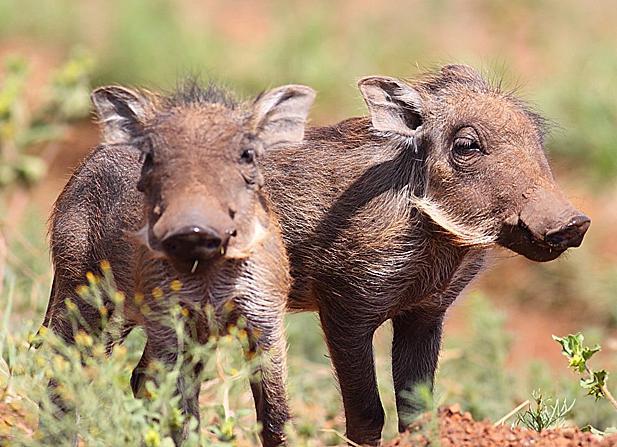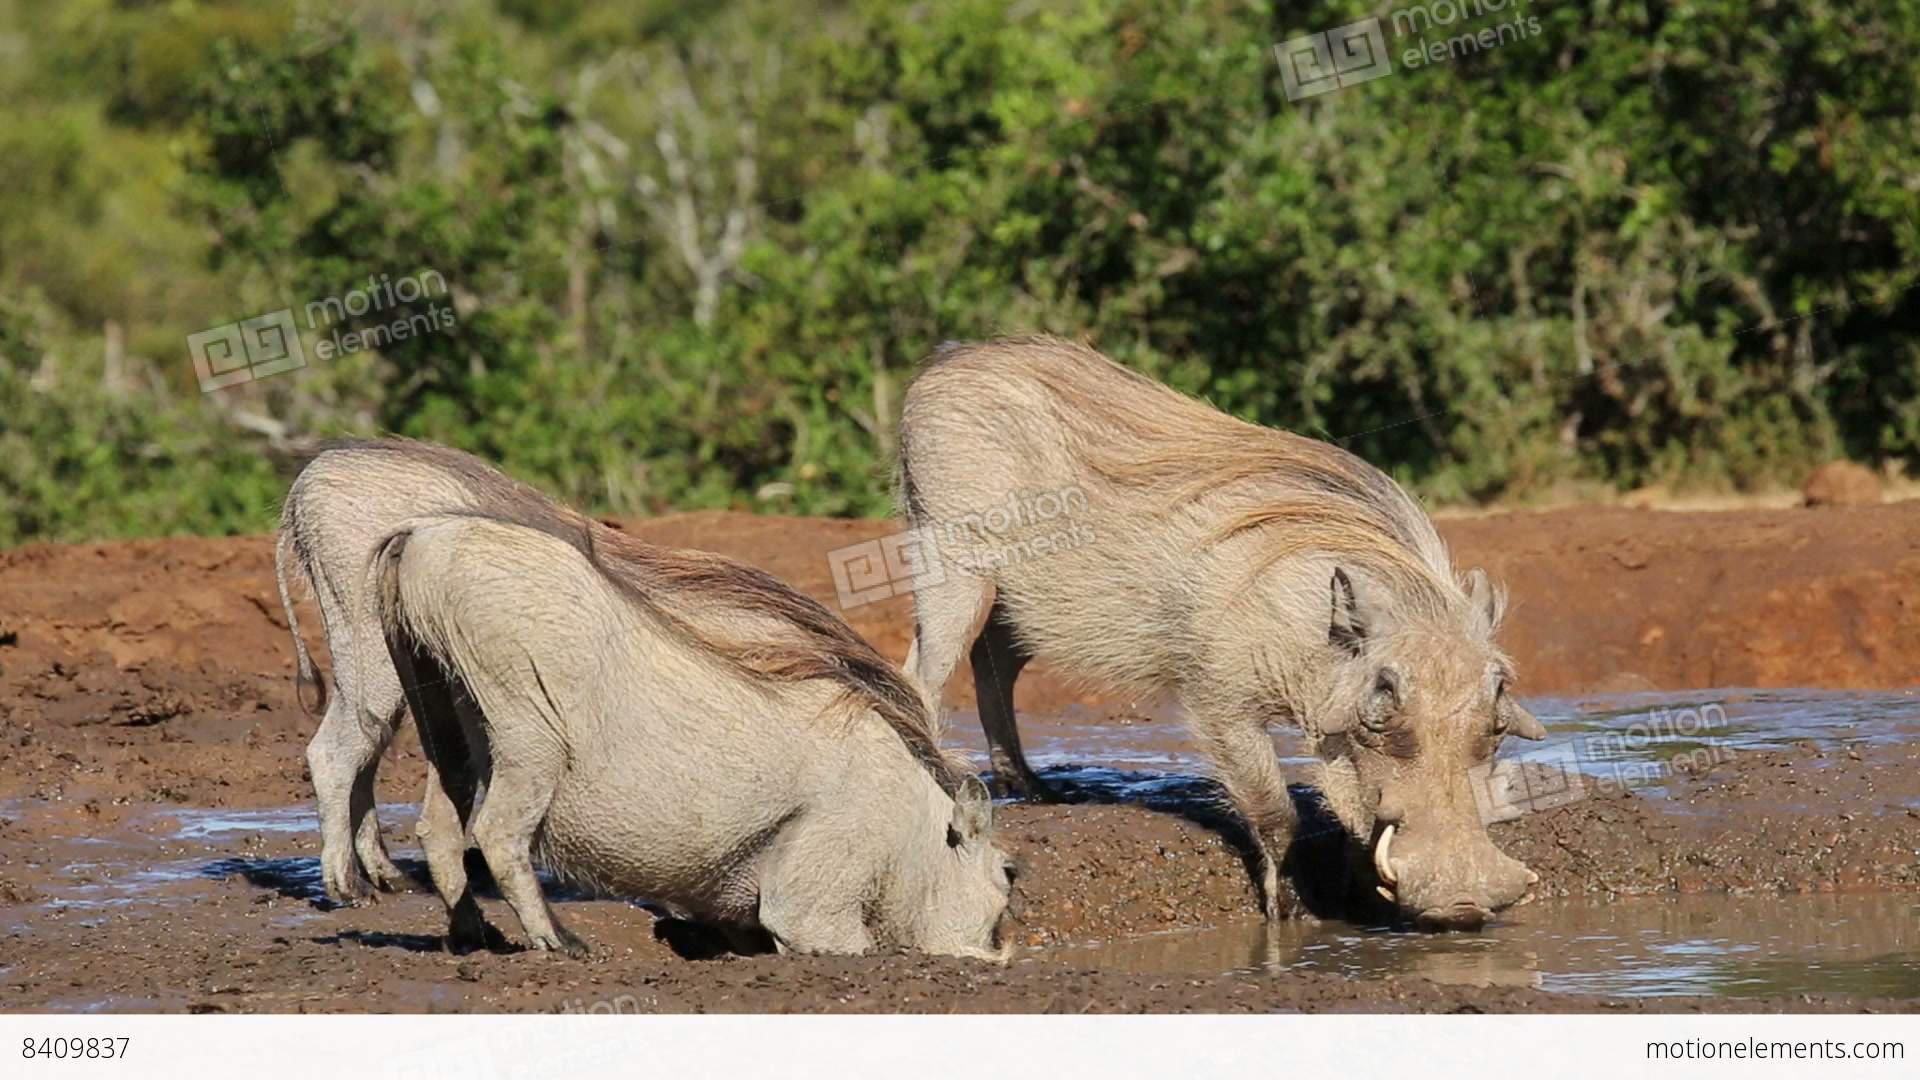The first image is the image on the left, the second image is the image on the right. Given the left and right images, does the statement "In one image two warthog is drinking out of a lake." hold true? Answer yes or no. Yes. The first image is the image on the left, the second image is the image on the right. For the images shown, is this caption "There are two wart hogs in the right image that are both facing towards the left." true? Answer yes or no. No. 